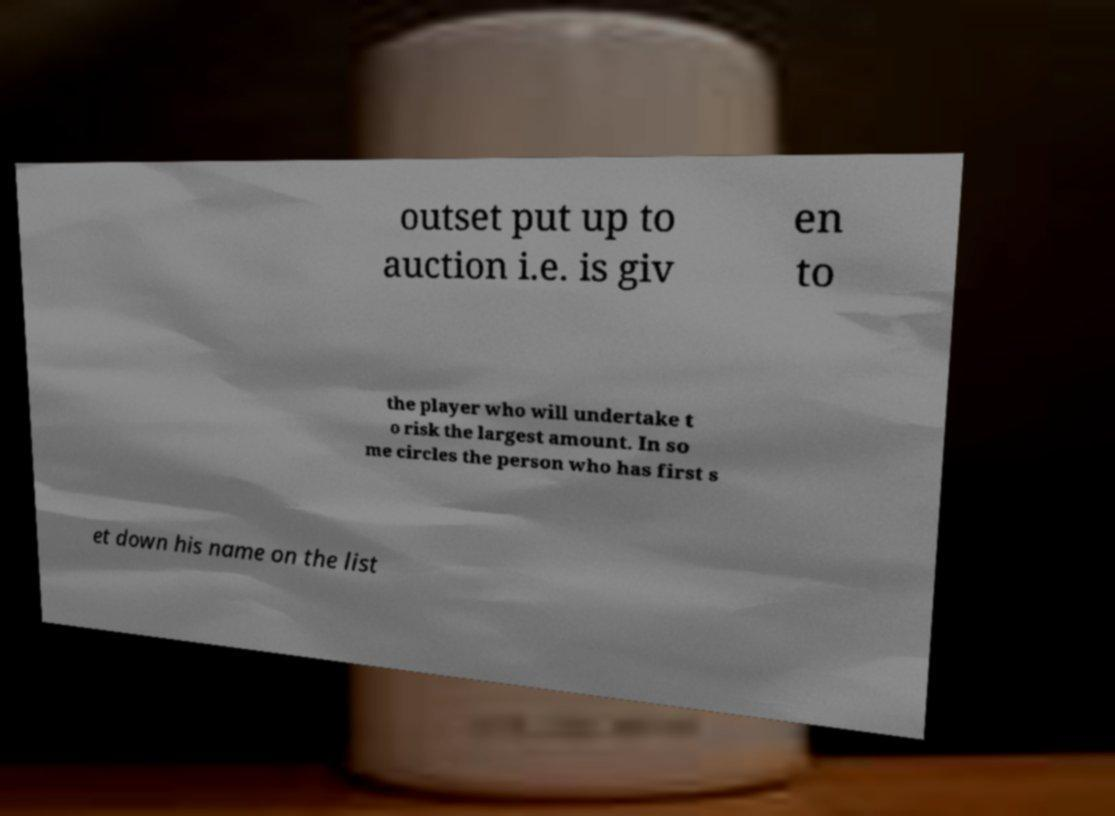I need the written content from this picture converted into text. Can you do that? outset put up to auction i.e. is giv en to the player who will undertake t o risk the largest amount. In so me circles the person who has first s et down his name on the list 